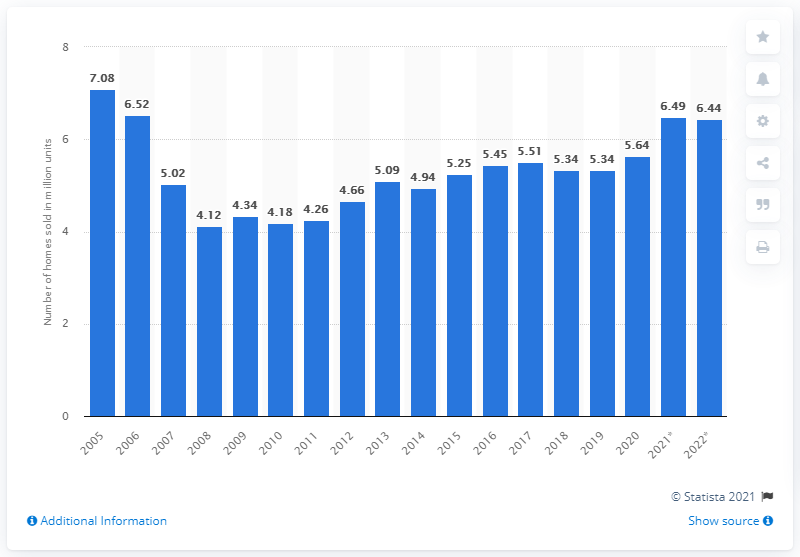Indicate a few pertinent items in this graphic. In 2020, a total of 5.64 homes were sold in the United States. 